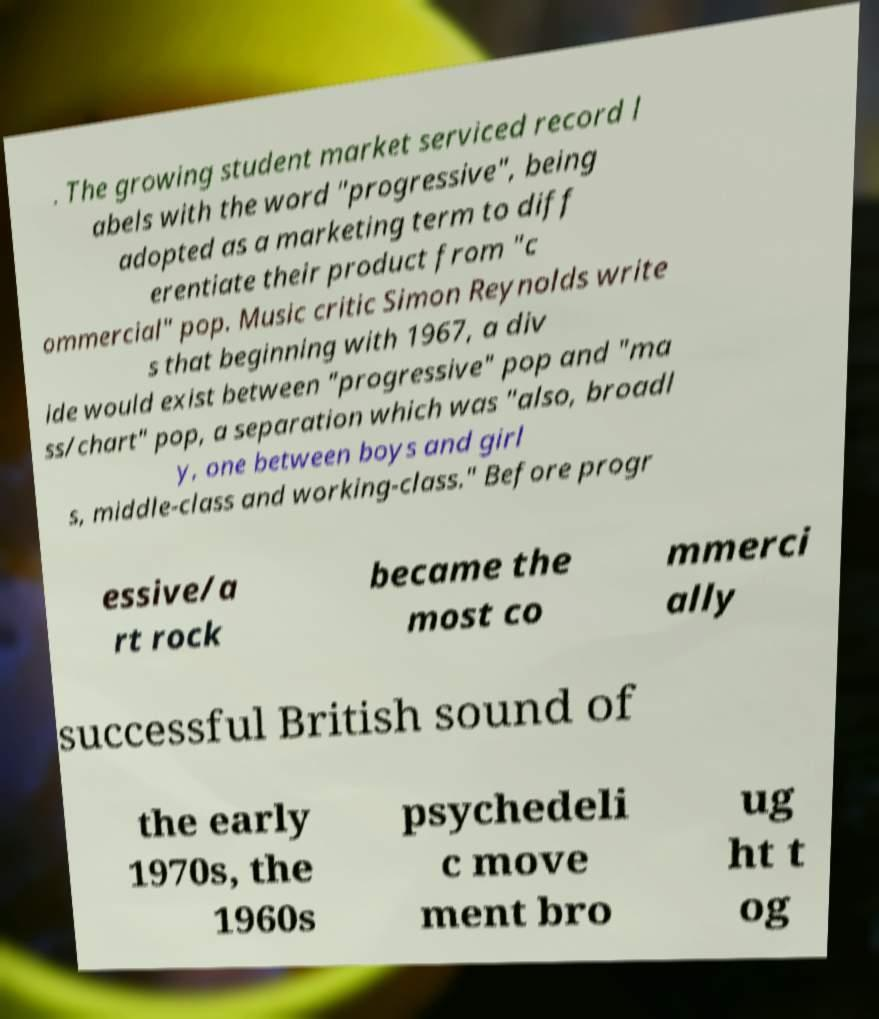What messages or text are displayed in this image? I need them in a readable, typed format. . The growing student market serviced record l abels with the word "progressive", being adopted as a marketing term to diff erentiate their product from "c ommercial" pop. Music critic Simon Reynolds write s that beginning with 1967, a div ide would exist between "progressive" pop and "ma ss/chart" pop, a separation which was "also, broadl y, one between boys and girl s, middle-class and working-class." Before progr essive/a rt rock became the most co mmerci ally successful British sound of the early 1970s, the 1960s psychedeli c move ment bro ug ht t og 